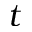Convert formula to latex. <formula><loc_0><loc_0><loc_500><loc_500>t</formula> 